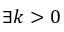<formula> <loc_0><loc_0><loc_500><loc_500>\exists k > 0</formula> 